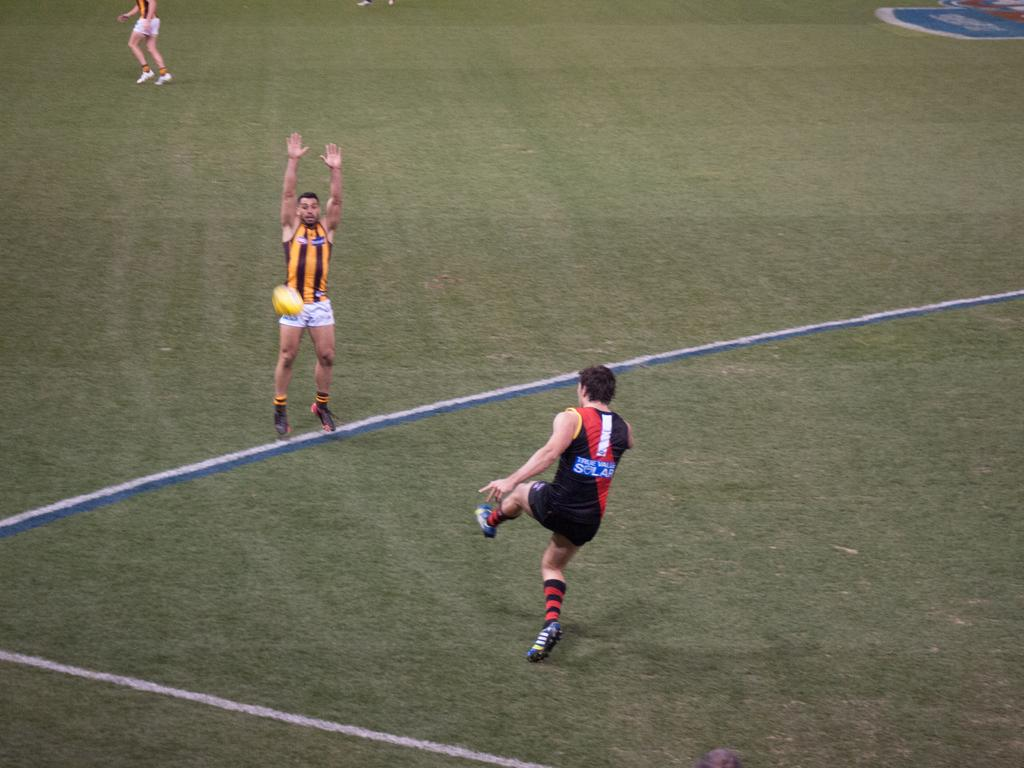What sport are the players engaged in within the image? The players are playing football. What surface are they playing on? There is a ground in the image where they are playing. Can you describe the players' activity in more detail? The players are actively participating in a game of football on the ground. How many sisters are present in the image? There is no mention of sisters in the image; it features players playing football on a ground. 